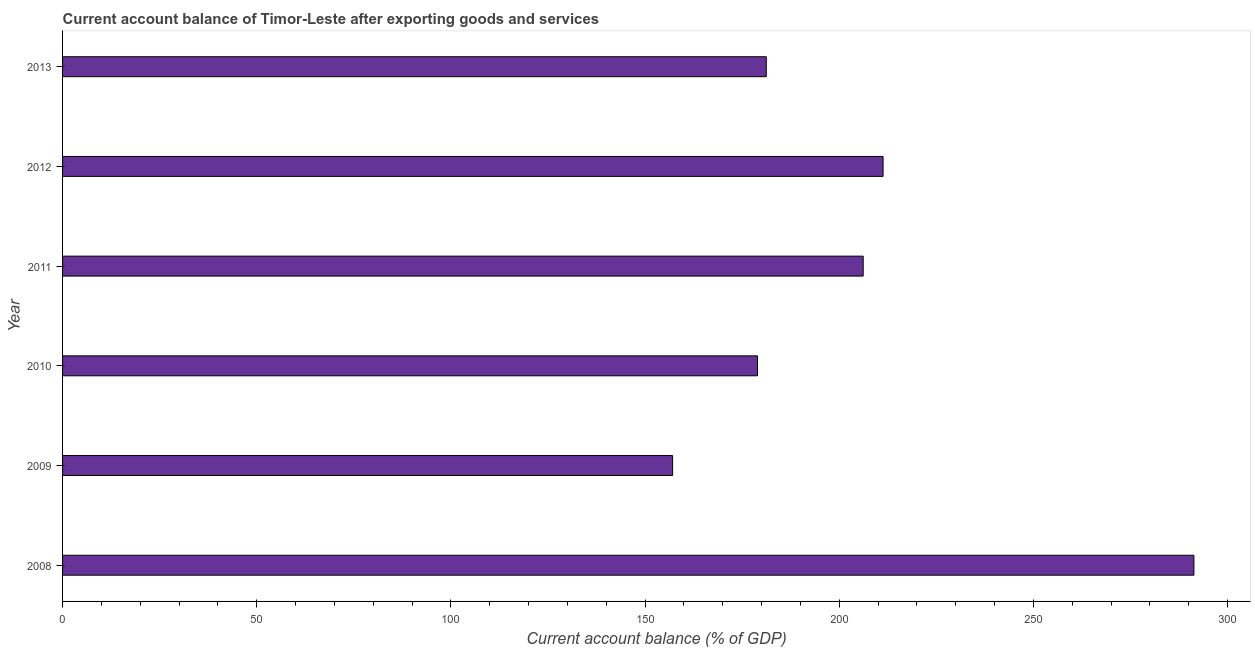Does the graph contain any zero values?
Ensure brevity in your answer.  No. What is the title of the graph?
Offer a terse response. Current account balance of Timor-Leste after exporting goods and services. What is the label or title of the X-axis?
Provide a short and direct response. Current account balance (% of GDP). What is the current account balance in 2012?
Offer a terse response. 211.28. Across all years, what is the maximum current account balance?
Provide a succinct answer. 291.32. Across all years, what is the minimum current account balance?
Provide a short and direct response. 157.09. In which year was the current account balance maximum?
Your answer should be very brief. 2008. In which year was the current account balance minimum?
Your answer should be very brief. 2009. What is the sum of the current account balance?
Make the answer very short. 1225.98. What is the difference between the current account balance in 2008 and 2009?
Provide a short and direct response. 134.23. What is the average current account balance per year?
Give a very brief answer. 204.33. What is the median current account balance?
Offer a terse response. 193.68. In how many years, is the current account balance greater than 100 %?
Provide a short and direct response. 6. Do a majority of the years between 2011 and 2010 (inclusive) have current account balance greater than 270 %?
Your answer should be very brief. No. What is the ratio of the current account balance in 2008 to that in 2009?
Ensure brevity in your answer.  1.85. Is the difference between the current account balance in 2008 and 2009 greater than the difference between any two years?
Give a very brief answer. Yes. What is the difference between the highest and the second highest current account balance?
Your response must be concise. 80.04. Is the sum of the current account balance in 2009 and 2011 greater than the maximum current account balance across all years?
Offer a very short reply. Yes. What is the difference between the highest and the lowest current account balance?
Keep it short and to the point. 134.23. Are all the bars in the graph horizontal?
Your answer should be compact. Yes. How many years are there in the graph?
Offer a terse response. 6. What is the difference between two consecutive major ticks on the X-axis?
Make the answer very short. 50. Are the values on the major ticks of X-axis written in scientific E-notation?
Provide a succinct answer. No. What is the Current account balance (% of GDP) of 2008?
Give a very brief answer. 291.32. What is the Current account balance (% of GDP) in 2009?
Provide a succinct answer. 157.09. What is the Current account balance (% of GDP) in 2010?
Make the answer very short. 178.95. What is the Current account balance (% of GDP) in 2011?
Give a very brief answer. 206.16. What is the Current account balance (% of GDP) in 2012?
Your answer should be very brief. 211.28. What is the Current account balance (% of GDP) of 2013?
Your answer should be very brief. 181.2. What is the difference between the Current account balance (% of GDP) in 2008 and 2009?
Give a very brief answer. 134.23. What is the difference between the Current account balance (% of GDP) in 2008 and 2010?
Your answer should be compact. 112.37. What is the difference between the Current account balance (% of GDP) in 2008 and 2011?
Your answer should be very brief. 85.16. What is the difference between the Current account balance (% of GDP) in 2008 and 2012?
Your answer should be very brief. 80.04. What is the difference between the Current account balance (% of GDP) in 2008 and 2013?
Your response must be concise. 110.12. What is the difference between the Current account balance (% of GDP) in 2009 and 2010?
Your response must be concise. -21.86. What is the difference between the Current account balance (% of GDP) in 2009 and 2011?
Offer a very short reply. -49.07. What is the difference between the Current account balance (% of GDP) in 2009 and 2012?
Provide a succinct answer. -54.19. What is the difference between the Current account balance (% of GDP) in 2009 and 2013?
Offer a terse response. -24.12. What is the difference between the Current account balance (% of GDP) in 2010 and 2011?
Provide a succinct answer. -27.21. What is the difference between the Current account balance (% of GDP) in 2010 and 2012?
Provide a short and direct response. -32.33. What is the difference between the Current account balance (% of GDP) in 2010 and 2013?
Give a very brief answer. -2.25. What is the difference between the Current account balance (% of GDP) in 2011 and 2012?
Offer a very short reply. -5.12. What is the difference between the Current account balance (% of GDP) in 2011 and 2013?
Ensure brevity in your answer.  24.95. What is the difference between the Current account balance (% of GDP) in 2012 and 2013?
Offer a very short reply. 30.07. What is the ratio of the Current account balance (% of GDP) in 2008 to that in 2009?
Offer a very short reply. 1.85. What is the ratio of the Current account balance (% of GDP) in 2008 to that in 2010?
Offer a terse response. 1.63. What is the ratio of the Current account balance (% of GDP) in 2008 to that in 2011?
Offer a very short reply. 1.41. What is the ratio of the Current account balance (% of GDP) in 2008 to that in 2012?
Your answer should be compact. 1.38. What is the ratio of the Current account balance (% of GDP) in 2008 to that in 2013?
Provide a succinct answer. 1.61. What is the ratio of the Current account balance (% of GDP) in 2009 to that in 2010?
Your answer should be very brief. 0.88. What is the ratio of the Current account balance (% of GDP) in 2009 to that in 2011?
Offer a terse response. 0.76. What is the ratio of the Current account balance (% of GDP) in 2009 to that in 2012?
Ensure brevity in your answer.  0.74. What is the ratio of the Current account balance (% of GDP) in 2009 to that in 2013?
Make the answer very short. 0.87. What is the ratio of the Current account balance (% of GDP) in 2010 to that in 2011?
Provide a short and direct response. 0.87. What is the ratio of the Current account balance (% of GDP) in 2010 to that in 2012?
Provide a short and direct response. 0.85. What is the ratio of the Current account balance (% of GDP) in 2010 to that in 2013?
Your response must be concise. 0.99. What is the ratio of the Current account balance (% of GDP) in 2011 to that in 2012?
Your response must be concise. 0.98. What is the ratio of the Current account balance (% of GDP) in 2011 to that in 2013?
Keep it short and to the point. 1.14. What is the ratio of the Current account balance (% of GDP) in 2012 to that in 2013?
Offer a very short reply. 1.17. 